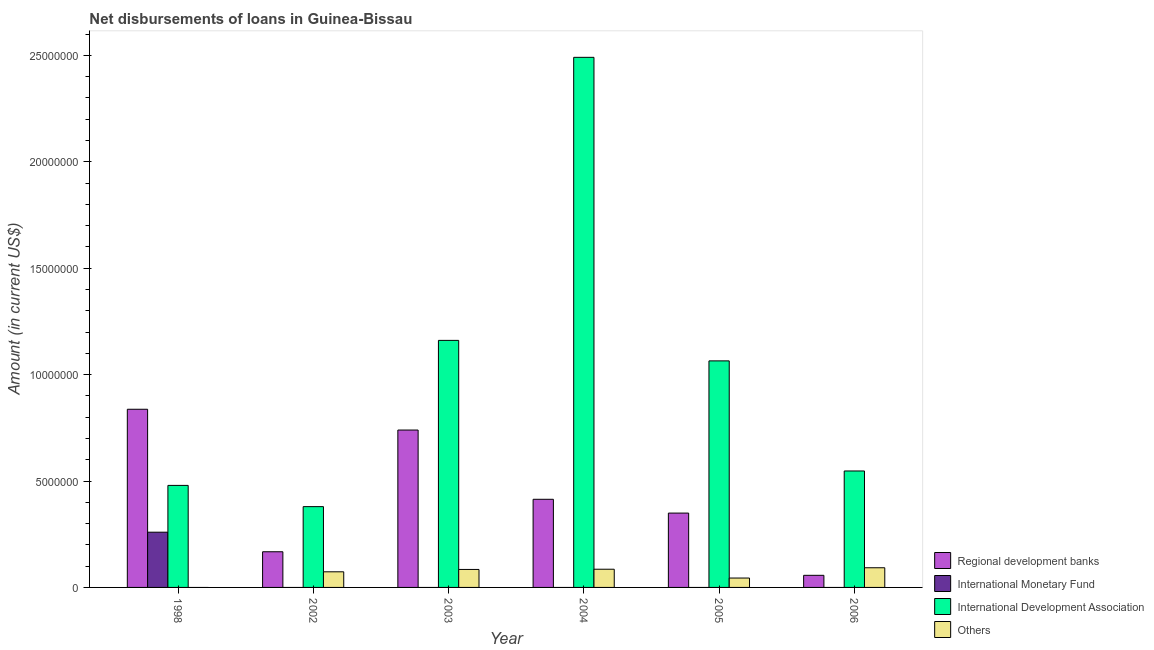How many different coloured bars are there?
Offer a very short reply. 4. Are the number of bars on each tick of the X-axis equal?
Ensure brevity in your answer.  Yes. How many bars are there on the 5th tick from the left?
Offer a terse response. 3. What is the label of the 1st group of bars from the left?
Offer a very short reply. 1998. In how many cases, is the number of bars for a given year not equal to the number of legend labels?
Make the answer very short. 6. What is the amount of loan disimbursed by regional development banks in 2006?
Make the answer very short. 5.69e+05. Across all years, what is the maximum amount of loan disimbursed by international development association?
Provide a succinct answer. 2.49e+07. What is the total amount of loan disimbursed by international development association in the graph?
Make the answer very short. 6.12e+07. What is the difference between the amount of loan disimbursed by other organisations in 2002 and that in 2004?
Offer a very short reply. -1.21e+05. What is the difference between the amount of loan disimbursed by international monetary fund in 1998 and the amount of loan disimbursed by regional development banks in 2006?
Make the answer very short. 2.60e+06. What is the average amount of loan disimbursed by other organisations per year?
Your answer should be compact. 6.33e+05. In the year 2006, what is the difference between the amount of loan disimbursed by international development association and amount of loan disimbursed by other organisations?
Offer a very short reply. 0. What is the ratio of the amount of loan disimbursed by international development association in 2003 to that in 2006?
Your answer should be compact. 2.12. What is the difference between the highest and the second highest amount of loan disimbursed by international development association?
Provide a short and direct response. 1.33e+07. What is the difference between the highest and the lowest amount of loan disimbursed by international monetary fund?
Give a very brief answer. 2.60e+06. Is the sum of the amount of loan disimbursed by regional development banks in 2003 and 2004 greater than the maximum amount of loan disimbursed by international development association across all years?
Keep it short and to the point. Yes. Is it the case that in every year, the sum of the amount of loan disimbursed by regional development banks and amount of loan disimbursed by international monetary fund is greater than the amount of loan disimbursed by international development association?
Your response must be concise. No. How many bars are there?
Give a very brief answer. 18. Are all the bars in the graph horizontal?
Your answer should be compact. No. What is the difference between two consecutive major ticks on the Y-axis?
Your answer should be very brief. 5.00e+06. Are the values on the major ticks of Y-axis written in scientific E-notation?
Offer a very short reply. No. Does the graph contain any zero values?
Keep it short and to the point. Yes. Where does the legend appear in the graph?
Offer a very short reply. Bottom right. What is the title of the graph?
Offer a terse response. Net disbursements of loans in Guinea-Bissau. Does "Management rating" appear as one of the legend labels in the graph?
Your answer should be very brief. No. What is the label or title of the Y-axis?
Offer a terse response. Amount (in current US$). What is the Amount (in current US$) of Regional development banks in 1998?
Ensure brevity in your answer.  8.37e+06. What is the Amount (in current US$) of International Monetary Fund in 1998?
Offer a very short reply. 2.60e+06. What is the Amount (in current US$) of International Development Association in 1998?
Give a very brief answer. 4.79e+06. What is the Amount (in current US$) in Others in 1998?
Ensure brevity in your answer.  0. What is the Amount (in current US$) in Regional development banks in 2002?
Your answer should be compact. 1.68e+06. What is the Amount (in current US$) in International Development Association in 2002?
Keep it short and to the point. 3.80e+06. What is the Amount (in current US$) in Others in 2002?
Keep it short and to the point. 7.34e+05. What is the Amount (in current US$) of Regional development banks in 2003?
Your answer should be compact. 7.40e+06. What is the Amount (in current US$) of International Development Association in 2003?
Offer a terse response. 1.16e+07. What is the Amount (in current US$) of Others in 2003?
Offer a very short reply. 8.45e+05. What is the Amount (in current US$) in Regional development banks in 2004?
Offer a terse response. 4.14e+06. What is the Amount (in current US$) in International Development Association in 2004?
Offer a very short reply. 2.49e+07. What is the Amount (in current US$) of Others in 2004?
Your response must be concise. 8.55e+05. What is the Amount (in current US$) in Regional development banks in 2005?
Provide a succinct answer. 3.49e+06. What is the Amount (in current US$) in International Monetary Fund in 2005?
Your answer should be compact. 0. What is the Amount (in current US$) in International Development Association in 2005?
Give a very brief answer. 1.06e+07. What is the Amount (in current US$) of Others in 2005?
Offer a terse response. 4.41e+05. What is the Amount (in current US$) in Regional development banks in 2006?
Provide a succinct answer. 5.69e+05. What is the Amount (in current US$) in International Development Association in 2006?
Ensure brevity in your answer.  5.47e+06. What is the Amount (in current US$) of Others in 2006?
Provide a succinct answer. 9.24e+05. Across all years, what is the maximum Amount (in current US$) in Regional development banks?
Keep it short and to the point. 8.37e+06. Across all years, what is the maximum Amount (in current US$) of International Monetary Fund?
Ensure brevity in your answer.  2.60e+06. Across all years, what is the maximum Amount (in current US$) of International Development Association?
Provide a succinct answer. 2.49e+07. Across all years, what is the maximum Amount (in current US$) in Others?
Offer a very short reply. 9.24e+05. Across all years, what is the minimum Amount (in current US$) in Regional development banks?
Your answer should be compact. 5.69e+05. Across all years, what is the minimum Amount (in current US$) in International Monetary Fund?
Keep it short and to the point. 0. Across all years, what is the minimum Amount (in current US$) in International Development Association?
Offer a terse response. 3.80e+06. Across all years, what is the minimum Amount (in current US$) in Others?
Make the answer very short. 0. What is the total Amount (in current US$) in Regional development banks in the graph?
Provide a succinct answer. 2.56e+07. What is the total Amount (in current US$) of International Monetary Fund in the graph?
Your answer should be compact. 2.60e+06. What is the total Amount (in current US$) of International Development Association in the graph?
Provide a short and direct response. 6.12e+07. What is the total Amount (in current US$) of Others in the graph?
Offer a very short reply. 3.80e+06. What is the difference between the Amount (in current US$) of Regional development banks in 1998 and that in 2002?
Provide a short and direct response. 6.70e+06. What is the difference between the Amount (in current US$) of International Development Association in 1998 and that in 2002?
Make the answer very short. 9.98e+05. What is the difference between the Amount (in current US$) of Regional development banks in 1998 and that in 2003?
Provide a succinct answer. 9.77e+05. What is the difference between the Amount (in current US$) of International Development Association in 1998 and that in 2003?
Make the answer very short. -6.81e+06. What is the difference between the Amount (in current US$) of Regional development banks in 1998 and that in 2004?
Keep it short and to the point. 4.23e+06. What is the difference between the Amount (in current US$) in International Development Association in 1998 and that in 2004?
Give a very brief answer. -2.01e+07. What is the difference between the Amount (in current US$) in Regional development banks in 1998 and that in 2005?
Your answer should be compact. 4.88e+06. What is the difference between the Amount (in current US$) in International Development Association in 1998 and that in 2005?
Give a very brief answer. -5.85e+06. What is the difference between the Amount (in current US$) of Regional development banks in 1998 and that in 2006?
Offer a very short reply. 7.80e+06. What is the difference between the Amount (in current US$) of International Development Association in 1998 and that in 2006?
Your answer should be compact. -6.78e+05. What is the difference between the Amount (in current US$) in Regional development banks in 2002 and that in 2003?
Provide a succinct answer. -5.72e+06. What is the difference between the Amount (in current US$) of International Development Association in 2002 and that in 2003?
Your answer should be compact. -7.81e+06. What is the difference between the Amount (in current US$) in Others in 2002 and that in 2003?
Your answer should be compact. -1.11e+05. What is the difference between the Amount (in current US$) in Regional development banks in 2002 and that in 2004?
Your response must be concise. -2.46e+06. What is the difference between the Amount (in current US$) of International Development Association in 2002 and that in 2004?
Your answer should be very brief. -2.11e+07. What is the difference between the Amount (in current US$) in Others in 2002 and that in 2004?
Your answer should be compact. -1.21e+05. What is the difference between the Amount (in current US$) in Regional development banks in 2002 and that in 2005?
Keep it short and to the point. -1.82e+06. What is the difference between the Amount (in current US$) in International Development Association in 2002 and that in 2005?
Offer a terse response. -6.85e+06. What is the difference between the Amount (in current US$) of Others in 2002 and that in 2005?
Your answer should be very brief. 2.93e+05. What is the difference between the Amount (in current US$) of Regional development banks in 2002 and that in 2006?
Your response must be concise. 1.11e+06. What is the difference between the Amount (in current US$) of International Development Association in 2002 and that in 2006?
Give a very brief answer. -1.68e+06. What is the difference between the Amount (in current US$) of Others in 2002 and that in 2006?
Give a very brief answer. -1.90e+05. What is the difference between the Amount (in current US$) of Regional development banks in 2003 and that in 2004?
Ensure brevity in your answer.  3.25e+06. What is the difference between the Amount (in current US$) in International Development Association in 2003 and that in 2004?
Ensure brevity in your answer.  -1.33e+07. What is the difference between the Amount (in current US$) in Others in 2003 and that in 2004?
Make the answer very short. -10000. What is the difference between the Amount (in current US$) in Regional development banks in 2003 and that in 2005?
Your answer should be very brief. 3.90e+06. What is the difference between the Amount (in current US$) in International Development Association in 2003 and that in 2005?
Make the answer very short. 9.63e+05. What is the difference between the Amount (in current US$) in Others in 2003 and that in 2005?
Provide a short and direct response. 4.04e+05. What is the difference between the Amount (in current US$) in Regional development banks in 2003 and that in 2006?
Provide a succinct answer. 6.83e+06. What is the difference between the Amount (in current US$) of International Development Association in 2003 and that in 2006?
Provide a succinct answer. 6.14e+06. What is the difference between the Amount (in current US$) in Others in 2003 and that in 2006?
Offer a very short reply. -7.90e+04. What is the difference between the Amount (in current US$) of Regional development banks in 2004 and that in 2005?
Provide a short and direct response. 6.48e+05. What is the difference between the Amount (in current US$) in International Development Association in 2004 and that in 2005?
Keep it short and to the point. 1.43e+07. What is the difference between the Amount (in current US$) in Others in 2004 and that in 2005?
Offer a terse response. 4.14e+05. What is the difference between the Amount (in current US$) in Regional development banks in 2004 and that in 2006?
Your answer should be compact. 3.57e+06. What is the difference between the Amount (in current US$) of International Development Association in 2004 and that in 2006?
Offer a terse response. 1.94e+07. What is the difference between the Amount (in current US$) in Others in 2004 and that in 2006?
Make the answer very short. -6.90e+04. What is the difference between the Amount (in current US$) of Regional development banks in 2005 and that in 2006?
Your answer should be compact. 2.92e+06. What is the difference between the Amount (in current US$) of International Development Association in 2005 and that in 2006?
Keep it short and to the point. 5.17e+06. What is the difference between the Amount (in current US$) in Others in 2005 and that in 2006?
Ensure brevity in your answer.  -4.83e+05. What is the difference between the Amount (in current US$) of Regional development banks in 1998 and the Amount (in current US$) of International Development Association in 2002?
Provide a succinct answer. 4.58e+06. What is the difference between the Amount (in current US$) of Regional development banks in 1998 and the Amount (in current US$) of Others in 2002?
Provide a short and direct response. 7.64e+06. What is the difference between the Amount (in current US$) of International Monetary Fund in 1998 and the Amount (in current US$) of International Development Association in 2002?
Offer a very short reply. -1.20e+06. What is the difference between the Amount (in current US$) of International Monetary Fund in 1998 and the Amount (in current US$) of Others in 2002?
Ensure brevity in your answer.  1.86e+06. What is the difference between the Amount (in current US$) in International Development Association in 1998 and the Amount (in current US$) in Others in 2002?
Your response must be concise. 4.06e+06. What is the difference between the Amount (in current US$) in Regional development banks in 1998 and the Amount (in current US$) in International Development Association in 2003?
Your answer should be very brief. -3.24e+06. What is the difference between the Amount (in current US$) of Regional development banks in 1998 and the Amount (in current US$) of Others in 2003?
Your response must be concise. 7.53e+06. What is the difference between the Amount (in current US$) in International Monetary Fund in 1998 and the Amount (in current US$) in International Development Association in 2003?
Provide a succinct answer. -9.01e+06. What is the difference between the Amount (in current US$) of International Monetary Fund in 1998 and the Amount (in current US$) of Others in 2003?
Your answer should be very brief. 1.75e+06. What is the difference between the Amount (in current US$) in International Development Association in 1998 and the Amount (in current US$) in Others in 2003?
Your answer should be very brief. 3.95e+06. What is the difference between the Amount (in current US$) of Regional development banks in 1998 and the Amount (in current US$) of International Development Association in 2004?
Your answer should be very brief. -1.65e+07. What is the difference between the Amount (in current US$) in Regional development banks in 1998 and the Amount (in current US$) in Others in 2004?
Offer a very short reply. 7.52e+06. What is the difference between the Amount (in current US$) of International Monetary Fund in 1998 and the Amount (in current US$) of International Development Association in 2004?
Your answer should be compact. -2.23e+07. What is the difference between the Amount (in current US$) in International Monetary Fund in 1998 and the Amount (in current US$) in Others in 2004?
Your answer should be compact. 1.74e+06. What is the difference between the Amount (in current US$) in International Development Association in 1998 and the Amount (in current US$) in Others in 2004?
Provide a short and direct response. 3.94e+06. What is the difference between the Amount (in current US$) of Regional development banks in 1998 and the Amount (in current US$) of International Development Association in 2005?
Your answer should be very brief. -2.27e+06. What is the difference between the Amount (in current US$) of Regional development banks in 1998 and the Amount (in current US$) of Others in 2005?
Ensure brevity in your answer.  7.93e+06. What is the difference between the Amount (in current US$) in International Monetary Fund in 1998 and the Amount (in current US$) in International Development Association in 2005?
Ensure brevity in your answer.  -8.05e+06. What is the difference between the Amount (in current US$) in International Monetary Fund in 1998 and the Amount (in current US$) in Others in 2005?
Offer a terse response. 2.15e+06. What is the difference between the Amount (in current US$) in International Development Association in 1998 and the Amount (in current US$) in Others in 2005?
Provide a short and direct response. 4.35e+06. What is the difference between the Amount (in current US$) of Regional development banks in 1998 and the Amount (in current US$) of International Development Association in 2006?
Ensure brevity in your answer.  2.90e+06. What is the difference between the Amount (in current US$) of Regional development banks in 1998 and the Amount (in current US$) of Others in 2006?
Give a very brief answer. 7.45e+06. What is the difference between the Amount (in current US$) in International Monetary Fund in 1998 and the Amount (in current US$) in International Development Association in 2006?
Your answer should be compact. -2.88e+06. What is the difference between the Amount (in current US$) of International Monetary Fund in 1998 and the Amount (in current US$) of Others in 2006?
Provide a succinct answer. 1.67e+06. What is the difference between the Amount (in current US$) in International Development Association in 1998 and the Amount (in current US$) in Others in 2006?
Your response must be concise. 3.87e+06. What is the difference between the Amount (in current US$) in Regional development banks in 2002 and the Amount (in current US$) in International Development Association in 2003?
Provide a short and direct response. -9.93e+06. What is the difference between the Amount (in current US$) of Regional development banks in 2002 and the Amount (in current US$) of Others in 2003?
Offer a very short reply. 8.31e+05. What is the difference between the Amount (in current US$) in International Development Association in 2002 and the Amount (in current US$) in Others in 2003?
Give a very brief answer. 2.95e+06. What is the difference between the Amount (in current US$) in Regional development banks in 2002 and the Amount (in current US$) in International Development Association in 2004?
Offer a terse response. -2.32e+07. What is the difference between the Amount (in current US$) in Regional development banks in 2002 and the Amount (in current US$) in Others in 2004?
Make the answer very short. 8.21e+05. What is the difference between the Amount (in current US$) in International Development Association in 2002 and the Amount (in current US$) in Others in 2004?
Make the answer very short. 2.94e+06. What is the difference between the Amount (in current US$) in Regional development banks in 2002 and the Amount (in current US$) in International Development Association in 2005?
Give a very brief answer. -8.97e+06. What is the difference between the Amount (in current US$) in Regional development banks in 2002 and the Amount (in current US$) in Others in 2005?
Provide a succinct answer. 1.24e+06. What is the difference between the Amount (in current US$) of International Development Association in 2002 and the Amount (in current US$) of Others in 2005?
Make the answer very short. 3.36e+06. What is the difference between the Amount (in current US$) of Regional development banks in 2002 and the Amount (in current US$) of International Development Association in 2006?
Give a very brief answer. -3.80e+06. What is the difference between the Amount (in current US$) of Regional development banks in 2002 and the Amount (in current US$) of Others in 2006?
Offer a very short reply. 7.52e+05. What is the difference between the Amount (in current US$) in International Development Association in 2002 and the Amount (in current US$) in Others in 2006?
Ensure brevity in your answer.  2.87e+06. What is the difference between the Amount (in current US$) of Regional development banks in 2003 and the Amount (in current US$) of International Development Association in 2004?
Your response must be concise. -1.75e+07. What is the difference between the Amount (in current US$) in Regional development banks in 2003 and the Amount (in current US$) in Others in 2004?
Ensure brevity in your answer.  6.54e+06. What is the difference between the Amount (in current US$) in International Development Association in 2003 and the Amount (in current US$) in Others in 2004?
Provide a short and direct response. 1.08e+07. What is the difference between the Amount (in current US$) in Regional development banks in 2003 and the Amount (in current US$) in International Development Association in 2005?
Your answer should be very brief. -3.25e+06. What is the difference between the Amount (in current US$) of Regional development banks in 2003 and the Amount (in current US$) of Others in 2005?
Ensure brevity in your answer.  6.95e+06. What is the difference between the Amount (in current US$) in International Development Association in 2003 and the Amount (in current US$) in Others in 2005?
Give a very brief answer. 1.12e+07. What is the difference between the Amount (in current US$) of Regional development banks in 2003 and the Amount (in current US$) of International Development Association in 2006?
Keep it short and to the point. 1.92e+06. What is the difference between the Amount (in current US$) in Regional development banks in 2003 and the Amount (in current US$) in Others in 2006?
Provide a short and direct response. 6.47e+06. What is the difference between the Amount (in current US$) of International Development Association in 2003 and the Amount (in current US$) of Others in 2006?
Keep it short and to the point. 1.07e+07. What is the difference between the Amount (in current US$) of Regional development banks in 2004 and the Amount (in current US$) of International Development Association in 2005?
Make the answer very short. -6.50e+06. What is the difference between the Amount (in current US$) of Regional development banks in 2004 and the Amount (in current US$) of Others in 2005?
Offer a terse response. 3.70e+06. What is the difference between the Amount (in current US$) of International Development Association in 2004 and the Amount (in current US$) of Others in 2005?
Provide a succinct answer. 2.45e+07. What is the difference between the Amount (in current US$) of Regional development banks in 2004 and the Amount (in current US$) of International Development Association in 2006?
Give a very brief answer. -1.33e+06. What is the difference between the Amount (in current US$) in Regional development banks in 2004 and the Amount (in current US$) in Others in 2006?
Offer a very short reply. 3.22e+06. What is the difference between the Amount (in current US$) of International Development Association in 2004 and the Amount (in current US$) of Others in 2006?
Your response must be concise. 2.40e+07. What is the difference between the Amount (in current US$) of Regional development banks in 2005 and the Amount (in current US$) of International Development Association in 2006?
Ensure brevity in your answer.  -1.98e+06. What is the difference between the Amount (in current US$) of Regional development banks in 2005 and the Amount (in current US$) of Others in 2006?
Your answer should be very brief. 2.57e+06. What is the difference between the Amount (in current US$) of International Development Association in 2005 and the Amount (in current US$) of Others in 2006?
Give a very brief answer. 9.72e+06. What is the average Amount (in current US$) of Regional development banks per year?
Ensure brevity in your answer.  4.27e+06. What is the average Amount (in current US$) in International Monetary Fund per year?
Give a very brief answer. 4.32e+05. What is the average Amount (in current US$) of International Development Association per year?
Your answer should be compact. 1.02e+07. What is the average Amount (in current US$) in Others per year?
Give a very brief answer. 6.33e+05. In the year 1998, what is the difference between the Amount (in current US$) of Regional development banks and Amount (in current US$) of International Monetary Fund?
Give a very brief answer. 5.78e+06. In the year 1998, what is the difference between the Amount (in current US$) of Regional development banks and Amount (in current US$) of International Development Association?
Give a very brief answer. 3.58e+06. In the year 1998, what is the difference between the Amount (in current US$) in International Monetary Fund and Amount (in current US$) in International Development Association?
Offer a very short reply. -2.20e+06. In the year 2002, what is the difference between the Amount (in current US$) in Regional development banks and Amount (in current US$) in International Development Association?
Provide a succinct answer. -2.12e+06. In the year 2002, what is the difference between the Amount (in current US$) in Regional development banks and Amount (in current US$) in Others?
Your response must be concise. 9.42e+05. In the year 2002, what is the difference between the Amount (in current US$) of International Development Association and Amount (in current US$) of Others?
Make the answer very short. 3.06e+06. In the year 2003, what is the difference between the Amount (in current US$) of Regional development banks and Amount (in current US$) of International Development Association?
Offer a terse response. -4.21e+06. In the year 2003, what is the difference between the Amount (in current US$) of Regional development banks and Amount (in current US$) of Others?
Make the answer very short. 6.55e+06. In the year 2003, what is the difference between the Amount (in current US$) of International Development Association and Amount (in current US$) of Others?
Offer a very short reply. 1.08e+07. In the year 2004, what is the difference between the Amount (in current US$) in Regional development banks and Amount (in current US$) in International Development Association?
Your response must be concise. -2.08e+07. In the year 2004, what is the difference between the Amount (in current US$) in Regional development banks and Amount (in current US$) in Others?
Provide a succinct answer. 3.29e+06. In the year 2004, what is the difference between the Amount (in current US$) of International Development Association and Amount (in current US$) of Others?
Your answer should be very brief. 2.41e+07. In the year 2005, what is the difference between the Amount (in current US$) of Regional development banks and Amount (in current US$) of International Development Association?
Provide a succinct answer. -7.15e+06. In the year 2005, what is the difference between the Amount (in current US$) of Regional development banks and Amount (in current US$) of Others?
Offer a very short reply. 3.05e+06. In the year 2005, what is the difference between the Amount (in current US$) of International Development Association and Amount (in current US$) of Others?
Provide a succinct answer. 1.02e+07. In the year 2006, what is the difference between the Amount (in current US$) in Regional development banks and Amount (in current US$) in International Development Association?
Give a very brief answer. -4.90e+06. In the year 2006, what is the difference between the Amount (in current US$) of Regional development banks and Amount (in current US$) of Others?
Your answer should be very brief. -3.55e+05. In the year 2006, what is the difference between the Amount (in current US$) in International Development Association and Amount (in current US$) in Others?
Your answer should be compact. 4.55e+06. What is the ratio of the Amount (in current US$) of Regional development banks in 1998 to that in 2002?
Your response must be concise. 5. What is the ratio of the Amount (in current US$) of International Development Association in 1998 to that in 2002?
Make the answer very short. 1.26. What is the ratio of the Amount (in current US$) in Regional development banks in 1998 to that in 2003?
Your response must be concise. 1.13. What is the ratio of the Amount (in current US$) of International Development Association in 1998 to that in 2003?
Provide a succinct answer. 0.41. What is the ratio of the Amount (in current US$) of Regional development banks in 1998 to that in 2004?
Offer a terse response. 2.02. What is the ratio of the Amount (in current US$) in International Development Association in 1998 to that in 2004?
Offer a very short reply. 0.19. What is the ratio of the Amount (in current US$) of Regional development banks in 1998 to that in 2005?
Make the answer very short. 2.4. What is the ratio of the Amount (in current US$) in International Development Association in 1998 to that in 2005?
Your answer should be compact. 0.45. What is the ratio of the Amount (in current US$) in Regional development banks in 1998 to that in 2006?
Your answer should be compact. 14.71. What is the ratio of the Amount (in current US$) in International Development Association in 1998 to that in 2006?
Make the answer very short. 0.88. What is the ratio of the Amount (in current US$) in Regional development banks in 2002 to that in 2003?
Offer a terse response. 0.23. What is the ratio of the Amount (in current US$) in International Development Association in 2002 to that in 2003?
Your response must be concise. 0.33. What is the ratio of the Amount (in current US$) in Others in 2002 to that in 2003?
Your answer should be very brief. 0.87. What is the ratio of the Amount (in current US$) of Regional development banks in 2002 to that in 2004?
Keep it short and to the point. 0.4. What is the ratio of the Amount (in current US$) in International Development Association in 2002 to that in 2004?
Keep it short and to the point. 0.15. What is the ratio of the Amount (in current US$) in Others in 2002 to that in 2004?
Make the answer very short. 0.86. What is the ratio of the Amount (in current US$) in Regional development banks in 2002 to that in 2005?
Keep it short and to the point. 0.48. What is the ratio of the Amount (in current US$) in International Development Association in 2002 to that in 2005?
Your answer should be very brief. 0.36. What is the ratio of the Amount (in current US$) in Others in 2002 to that in 2005?
Keep it short and to the point. 1.66. What is the ratio of the Amount (in current US$) of Regional development banks in 2002 to that in 2006?
Your response must be concise. 2.95. What is the ratio of the Amount (in current US$) of International Development Association in 2002 to that in 2006?
Make the answer very short. 0.69. What is the ratio of the Amount (in current US$) in Others in 2002 to that in 2006?
Make the answer very short. 0.79. What is the ratio of the Amount (in current US$) in Regional development banks in 2003 to that in 2004?
Your response must be concise. 1.79. What is the ratio of the Amount (in current US$) in International Development Association in 2003 to that in 2004?
Keep it short and to the point. 0.47. What is the ratio of the Amount (in current US$) of Others in 2003 to that in 2004?
Provide a succinct answer. 0.99. What is the ratio of the Amount (in current US$) in Regional development banks in 2003 to that in 2005?
Make the answer very short. 2.12. What is the ratio of the Amount (in current US$) of International Development Association in 2003 to that in 2005?
Give a very brief answer. 1.09. What is the ratio of the Amount (in current US$) in Others in 2003 to that in 2005?
Offer a very short reply. 1.92. What is the ratio of the Amount (in current US$) of Regional development banks in 2003 to that in 2006?
Offer a terse response. 13. What is the ratio of the Amount (in current US$) in International Development Association in 2003 to that in 2006?
Keep it short and to the point. 2.12. What is the ratio of the Amount (in current US$) of Others in 2003 to that in 2006?
Offer a very short reply. 0.91. What is the ratio of the Amount (in current US$) of Regional development banks in 2004 to that in 2005?
Your answer should be compact. 1.19. What is the ratio of the Amount (in current US$) in International Development Association in 2004 to that in 2005?
Ensure brevity in your answer.  2.34. What is the ratio of the Amount (in current US$) of Others in 2004 to that in 2005?
Your answer should be very brief. 1.94. What is the ratio of the Amount (in current US$) in Regional development banks in 2004 to that in 2006?
Offer a terse response. 7.28. What is the ratio of the Amount (in current US$) in International Development Association in 2004 to that in 2006?
Your response must be concise. 4.55. What is the ratio of the Amount (in current US$) of Others in 2004 to that in 2006?
Provide a short and direct response. 0.93. What is the ratio of the Amount (in current US$) of Regional development banks in 2005 to that in 2006?
Provide a short and direct response. 6.14. What is the ratio of the Amount (in current US$) in International Development Association in 2005 to that in 2006?
Your response must be concise. 1.95. What is the ratio of the Amount (in current US$) of Others in 2005 to that in 2006?
Offer a terse response. 0.48. What is the difference between the highest and the second highest Amount (in current US$) of Regional development banks?
Provide a short and direct response. 9.77e+05. What is the difference between the highest and the second highest Amount (in current US$) of International Development Association?
Offer a terse response. 1.33e+07. What is the difference between the highest and the second highest Amount (in current US$) in Others?
Offer a terse response. 6.90e+04. What is the difference between the highest and the lowest Amount (in current US$) of Regional development banks?
Give a very brief answer. 7.80e+06. What is the difference between the highest and the lowest Amount (in current US$) in International Monetary Fund?
Your answer should be compact. 2.60e+06. What is the difference between the highest and the lowest Amount (in current US$) of International Development Association?
Make the answer very short. 2.11e+07. What is the difference between the highest and the lowest Amount (in current US$) in Others?
Your response must be concise. 9.24e+05. 